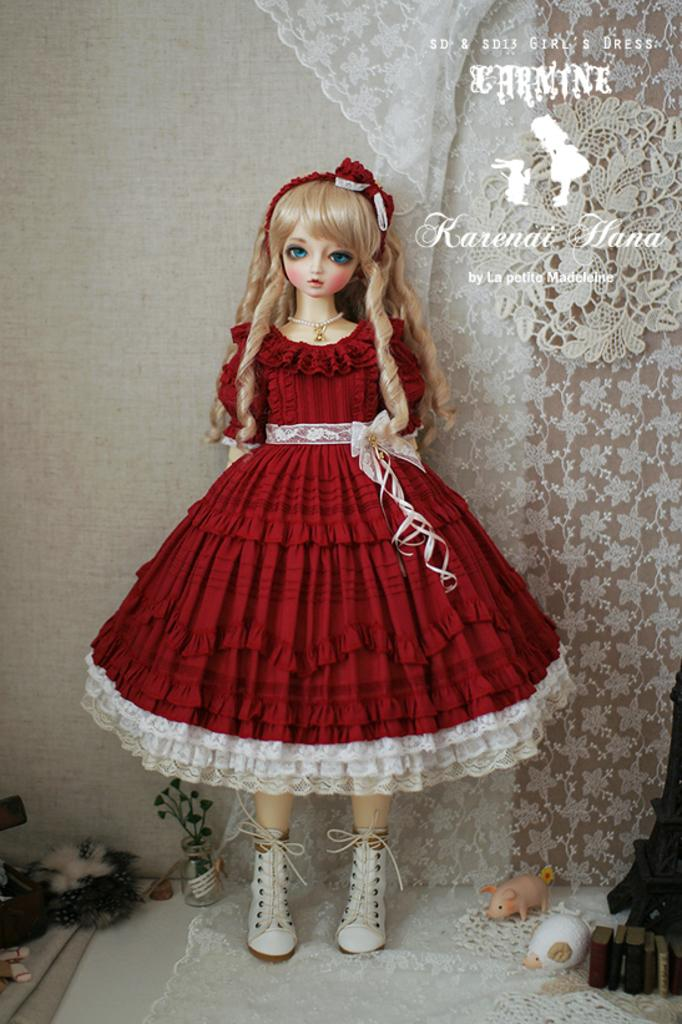What is the doll standing on in the image? The doll is standing on a cloth in the image. What other items can be seen in the image besides the doll? There are toys, books, a plant in a glass vase, and various objects on the surface visible in the image. What type of container is the plant in? The plant is in a glass vase in the image. What is the color of the cloth in the image? The cloth in the image is white. What can be seen on the wall in the image? There is some text visible on the wall in the image. What type of butter is being used as an example in the image? There is no butter present in the image. 